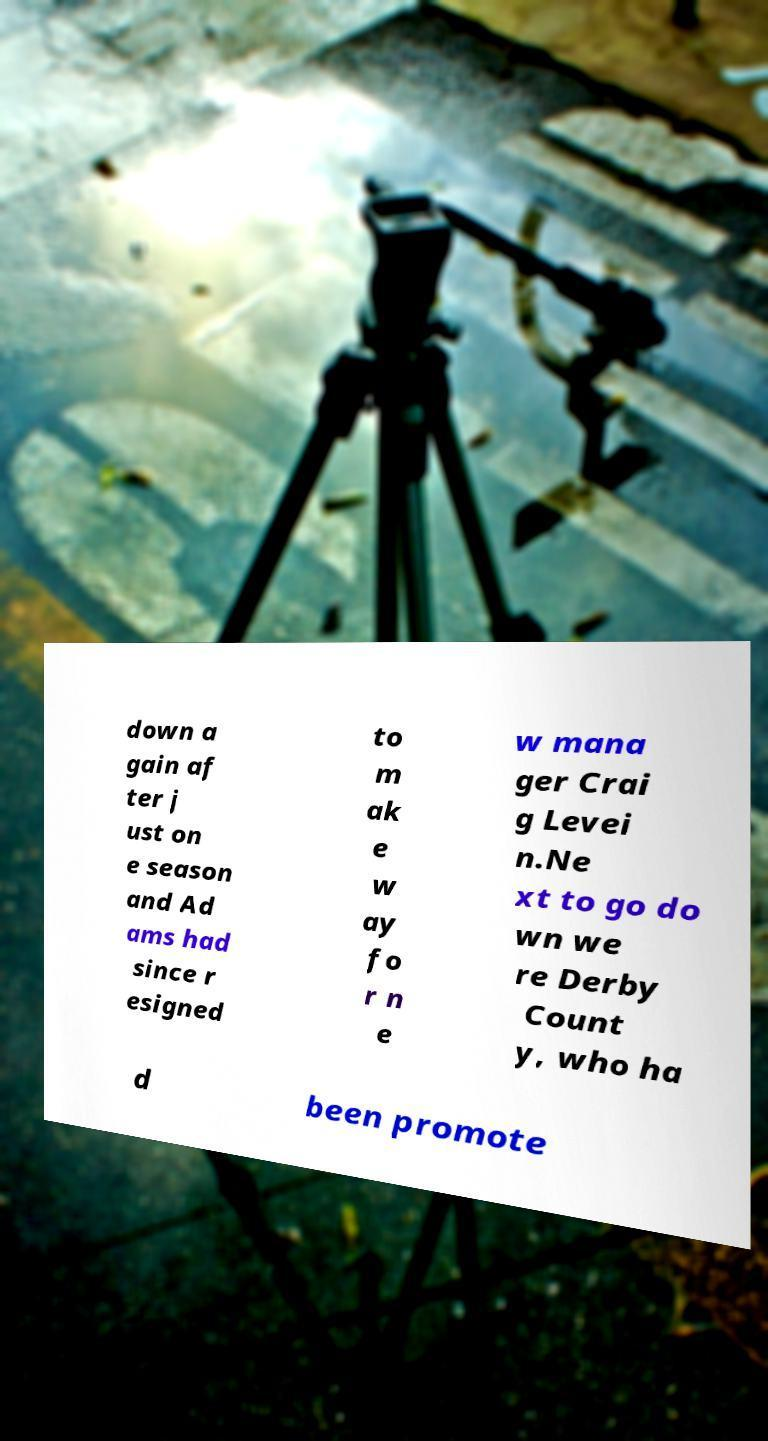Could you assist in decoding the text presented in this image and type it out clearly? down a gain af ter j ust on e season and Ad ams had since r esigned to m ak e w ay fo r n e w mana ger Crai g Levei n.Ne xt to go do wn we re Derby Count y, who ha d been promote 